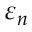Convert formula to latex. <formula><loc_0><loc_0><loc_500><loc_500>\varepsilon _ { n }</formula> 